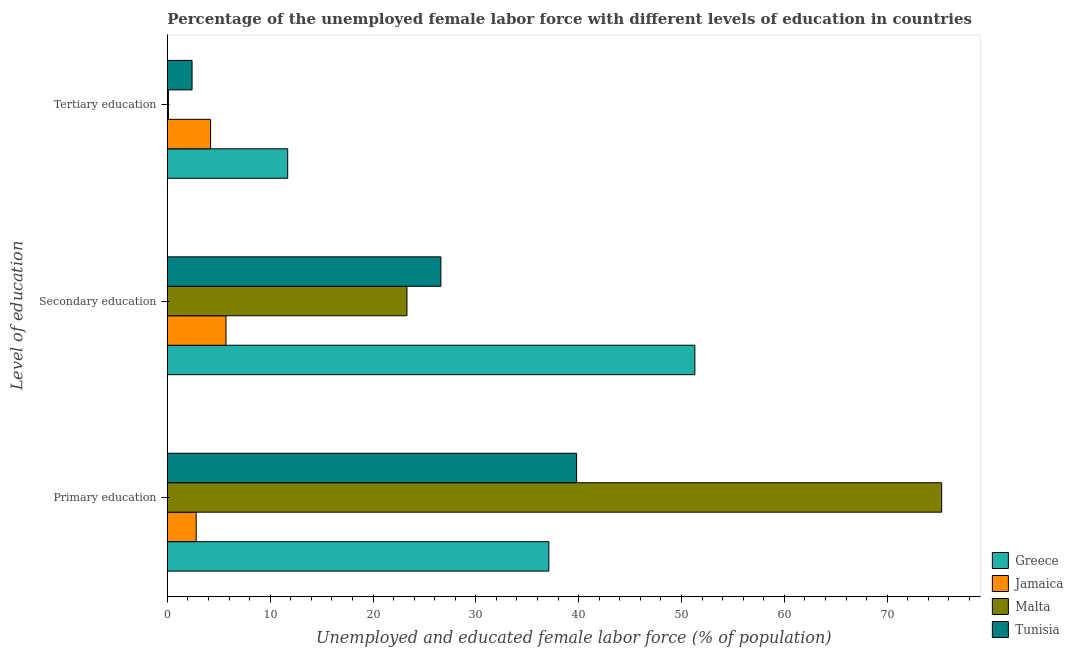How many different coloured bars are there?
Your answer should be compact. 4. Are the number of bars on each tick of the Y-axis equal?
Keep it short and to the point. Yes. How many bars are there on the 1st tick from the top?
Give a very brief answer. 4. What is the label of the 1st group of bars from the top?
Offer a very short reply. Tertiary education. What is the percentage of female labor force who received tertiary education in Malta?
Keep it short and to the point. 0.1. Across all countries, what is the maximum percentage of female labor force who received tertiary education?
Your response must be concise. 11.7. Across all countries, what is the minimum percentage of female labor force who received secondary education?
Keep it short and to the point. 5.7. In which country was the percentage of female labor force who received primary education minimum?
Keep it short and to the point. Jamaica. What is the total percentage of female labor force who received tertiary education in the graph?
Offer a very short reply. 18.4. What is the difference between the percentage of female labor force who received secondary education in Greece and that in Jamaica?
Your response must be concise. 45.6. What is the difference between the percentage of female labor force who received primary education in Greece and the percentage of female labor force who received tertiary education in Jamaica?
Give a very brief answer. 32.9. What is the average percentage of female labor force who received primary education per country?
Give a very brief answer. 38.75. What is the difference between the percentage of female labor force who received primary education and percentage of female labor force who received tertiary education in Tunisia?
Provide a short and direct response. 37.4. In how many countries, is the percentage of female labor force who received primary education greater than 72 %?
Your answer should be very brief. 1. What is the ratio of the percentage of female labor force who received secondary education in Jamaica to that in Malta?
Make the answer very short. 0.24. Is the percentage of female labor force who received secondary education in Jamaica less than that in Tunisia?
Your response must be concise. Yes. What is the difference between the highest and the second highest percentage of female labor force who received tertiary education?
Give a very brief answer. 7.5. What is the difference between the highest and the lowest percentage of female labor force who received secondary education?
Provide a short and direct response. 45.6. Is the sum of the percentage of female labor force who received primary education in Jamaica and Malta greater than the maximum percentage of female labor force who received secondary education across all countries?
Your answer should be very brief. Yes. What does the 3rd bar from the top in Secondary education represents?
Give a very brief answer. Jamaica. What does the 4th bar from the bottom in Primary education represents?
Ensure brevity in your answer.  Tunisia. How many countries are there in the graph?
Make the answer very short. 4. Are the values on the major ticks of X-axis written in scientific E-notation?
Your answer should be compact. No. How are the legend labels stacked?
Provide a succinct answer. Vertical. What is the title of the graph?
Make the answer very short. Percentage of the unemployed female labor force with different levels of education in countries. What is the label or title of the X-axis?
Make the answer very short. Unemployed and educated female labor force (% of population). What is the label or title of the Y-axis?
Your answer should be compact. Level of education. What is the Unemployed and educated female labor force (% of population) in Greece in Primary education?
Provide a succinct answer. 37.1. What is the Unemployed and educated female labor force (% of population) in Jamaica in Primary education?
Provide a succinct answer. 2.8. What is the Unemployed and educated female labor force (% of population) of Malta in Primary education?
Give a very brief answer. 75.3. What is the Unemployed and educated female labor force (% of population) of Tunisia in Primary education?
Make the answer very short. 39.8. What is the Unemployed and educated female labor force (% of population) of Greece in Secondary education?
Ensure brevity in your answer.  51.3. What is the Unemployed and educated female labor force (% of population) of Jamaica in Secondary education?
Provide a succinct answer. 5.7. What is the Unemployed and educated female labor force (% of population) of Malta in Secondary education?
Make the answer very short. 23.3. What is the Unemployed and educated female labor force (% of population) in Tunisia in Secondary education?
Ensure brevity in your answer.  26.6. What is the Unemployed and educated female labor force (% of population) of Greece in Tertiary education?
Give a very brief answer. 11.7. What is the Unemployed and educated female labor force (% of population) in Jamaica in Tertiary education?
Provide a short and direct response. 4.2. What is the Unemployed and educated female labor force (% of population) in Malta in Tertiary education?
Give a very brief answer. 0.1. What is the Unemployed and educated female labor force (% of population) of Tunisia in Tertiary education?
Ensure brevity in your answer.  2.4. Across all Level of education, what is the maximum Unemployed and educated female labor force (% of population) in Greece?
Keep it short and to the point. 51.3. Across all Level of education, what is the maximum Unemployed and educated female labor force (% of population) in Jamaica?
Make the answer very short. 5.7. Across all Level of education, what is the maximum Unemployed and educated female labor force (% of population) of Malta?
Provide a succinct answer. 75.3. Across all Level of education, what is the maximum Unemployed and educated female labor force (% of population) of Tunisia?
Offer a terse response. 39.8. Across all Level of education, what is the minimum Unemployed and educated female labor force (% of population) in Greece?
Offer a terse response. 11.7. Across all Level of education, what is the minimum Unemployed and educated female labor force (% of population) in Jamaica?
Ensure brevity in your answer.  2.8. Across all Level of education, what is the minimum Unemployed and educated female labor force (% of population) in Malta?
Provide a short and direct response. 0.1. Across all Level of education, what is the minimum Unemployed and educated female labor force (% of population) of Tunisia?
Offer a terse response. 2.4. What is the total Unemployed and educated female labor force (% of population) of Greece in the graph?
Your answer should be compact. 100.1. What is the total Unemployed and educated female labor force (% of population) in Malta in the graph?
Offer a very short reply. 98.7. What is the total Unemployed and educated female labor force (% of population) in Tunisia in the graph?
Keep it short and to the point. 68.8. What is the difference between the Unemployed and educated female labor force (% of population) of Greece in Primary education and that in Tertiary education?
Make the answer very short. 25.4. What is the difference between the Unemployed and educated female labor force (% of population) in Malta in Primary education and that in Tertiary education?
Offer a very short reply. 75.2. What is the difference between the Unemployed and educated female labor force (% of population) of Tunisia in Primary education and that in Tertiary education?
Make the answer very short. 37.4. What is the difference between the Unemployed and educated female labor force (% of population) of Greece in Secondary education and that in Tertiary education?
Keep it short and to the point. 39.6. What is the difference between the Unemployed and educated female labor force (% of population) of Malta in Secondary education and that in Tertiary education?
Offer a terse response. 23.2. What is the difference between the Unemployed and educated female labor force (% of population) of Tunisia in Secondary education and that in Tertiary education?
Provide a short and direct response. 24.2. What is the difference between the Unemployed and educated female labor force (% of population) in Greece in Primary education and the Unemployed and educated female labor force (% of population) in Jamaica in Secondary education?
Give a very brief answer. 31.4. What is the difference between the Unemployed and educated female labor force (% of population) of Greece in Primary education and the Unemployed and educated female labor force (% of population) of Tunisia in Secondary education?
Your response must be concise. 10.5. What is the difference between the Unemployed and educated female labor force (% of population) in Jamaica in Primary education and the Unemployed and educated female labor force (% of population) in Malta in Secondary education?
Offer a terse response. -20.5. What is the difference between the Unemployed and educated female labor force (% of population) of Jamaica in Primary education and the Unemployed and educated female labor force (% of population) of Tunisia in Secondary education?
Offer a terse response. -23.8. What is the difference between the Unemployed and educated female labor force (% of population) of Malta in Primary education and the Unemployed and educated female labor force (% of population) of Tunisia in Secondary education?
Provide a short and direct response. 48.7. What is the difference between the Unemployed and educated female labor force (% of population) of Greece in Primary education and the Unemployed and educated female labor force (% of population) of Jamaica in Tertiary education?
Offer a very short reply. 32.9. What is the difference between the Unemployed and educated female labor force (% of population) of Greece in Primary education and the Unemployed and educated female labor force (% of population) of Tunisia in Tertiary education?
Provide a short and direct response. 34.7. What is the difference between the Unemployed and educated female labor force (% of population) of Malta in Primary education and the Unemployed and educated female labor force (% of population) of Tunisia in Tertiary education?
Make the answer very short. 72.9. What is the difference between the Unemployed and educated female labor force (% of population) of Greece in Secondary education and the Unemployed and educated female labor force (% of population) of Jamaica in Tertiary education?
Make the answer very short. 47.1. What is the difference between the Unemployed and educated female labor force (% of population) of Greece in Secondary education and the Unemployed and educated female labor force (% of population) of Malta in Tertiary education?
Keep it short and to the point. 51.2. What is the difference between the Unemployed and educated female labor force (% of population) in Greece in Secondary education and the Unemployed and educated female labor force (% of population) in Tunisia in Tertiary education?
Make the answer very short. 48.9. What is the difference between the Unemployed and educated female labor force (% of population) of Jamaica in Secondary education and the Unemployed and educated female labor force (% of population) of Malta in Tertiary education?
Your answer should be compact. 5.6. What is the difference between the Unemployed and educated female labor force (% of population) in Malta in Secondary education and the Unemployed and educated female labor force (% of population) in Tunisia in Tertiary education?
Provide a succinct answer. 20.9. What is the average Unemployed and educated female labor force (% of population) in Greece per Level of education?
Make the answer very short. 33.37. What is the average Unemployed and educated female labor force (% of population) of Jamaica per Level of education?
Make the answer very short. 4.23. What is the average Unemployed and educated female labor force (% of population) in Malta per Level of education?
Your answer should be very brief. 32.9. What is the average Unemployed and educated female labor force (% of population) in Tunisia per Level of education?
Keep it short and to the point. 22.93. What is the difference between the Unemployed and educated female labor force (% of population) of Greece and Unemployed and educated female labor force (% of population) of Jamaica in Primary education?
Your answer should be compact. 34.3. What is the difference between the Unemployed and educated female labor force (% of population) in Greece and Unemployed and educated female labor force (% of population) in Malta in Primary education?
Ensure brevity in your answer.  -38.2. What is the difference between the Unemployed and educated female labor force (% of population) in Greece and Unemployed and educated female labor force (% of population) in Tunisia in Primary education?
Your answer should be very brief. -2.7. What is the difference between the Unemployed and educated female labor force (% of population) in Jamaica and Unemployed and educated female labor force (% of population) in Malta in Primary education?
Offer a very short reply. -72.5. What is the difference between the Unemployed and educated female labor force (% of population) of Jamaica and Unemployed and educated female labor force (% of population) of Tunisia in Primary education?
Offer a very short reply. -37. What is the difference between the Unemployed and educated female labor force (% of population) of Malta and Unemployed and educated female labor force (% of population) of Tunisia in Primary education?
Ensure brevity in your answer.  35.5. What is the difference between the Unemployed and educated female labor force (% of population) in Greece and Unemployed and educated female labor force (% of population) in Jamaica in Secondary education?
Your answer should be very brief. 45.6. What is the difference between the Unemployed and educated female labor force (% of population) of Greece and Unemployed and educated female labor force (% of population) of Tunisia in Secondary education?
Your answer should be very brief. 24.7. What is the difference between the Unemployed and educated female labor force (% of population) in Jamaica and Unemployed and educated female labor force (% of population) in Malta in Secondary education?
Keep it short and to the point. -17.6. What is the difference between the Unemployed and educated female labor force (% of population) in Jamaica and Unemployed and educated female labor force (% of population) in Tunisia in Secondary education?
Your response must be concise. -20.9. What is the difference between the Unemployed and educated female labor force (% of population) in Malta and Unemployed and educated female labor force (% of population) in Tunisia in Secondary education?
Ensure brevity in your answer.  -3.3. What is the difference between the Unemployed and educated female labor force (% of population) in Greece and Unemployed and educated female labor force (% of population) in Jamaica in Tertiary education?
Your answer should be compact. 7.5. What is the difference between the Unemployed and educated female labor force (% of population) in Greece and Unemployed and educated female labor force (% of population) in Tunisia in Tertiary education?
Provide a short and direct response. 9.3. What is the difference between the Unemployed and educated female labor force (% of population) in Malta and Unemployed and educated female labor force (% of population) in Tunisia in Tertiary education?
Your response must be concise. -2.3. What is the ratio of the Unemployed and educated female labor force (% of population) in Greece in Primary education to that in Secondary education?
Your answer should be very brief. 0.72. What is the ratio of the Unemployed and educated female labor force (% of population) of Jamaica in Primary education to that in Secondary education?
Offer a very short reply. 0.49. What is the ratio of the Unemployed and educated female labor force (% of population) of Malta in Primary education to that in Secondary education?
Provide a short and direct response. 3.23. What is the ratio of the Unemployed and educated female labor force (% of population) of Tunisia in Primary education to that in Secondary education?
Your answer should be compact. 1.5. What is the ratio of the Unemployed and educated female labor force (% of population) in Greece in Primary education to that in Tertiary education?
Your answer should be compact. 3.17. What is the ratio of the Unemployed and educated female labor force (% of population) of Malta in Primary education to that in Tertiary education?
Provide a succinct answer. 753. What is the ratio of the Unemployed and educated female labor force (% of population) of Tunisia in Primary education to that in Tertiary education?
Your response must be concise. 16.58. What is the ratio of the Unemployed and educated female labor force (% of population) in Greece in Secondary education to that in Tertiary education?
Ensure brevity in your answer.  4.38. What is the ratio of the Unemployed and educated female labor force (% of population) of Jamaica in Secondary education to that in Tertiary education?
Give a very brief answer. 1.36. What is the ratio of the Unemployed and educated female labor force (% of population) in Malta in Secondary education to that in Tertiary education?
Your response must be concise. 233. What is the ratio of the Unemployed and educated female labor force (% of population) of Tunisia in Secondary education to that in Tertiary education?
Make the answer very short. 11.08. What is the difference between the highest and the second highest Unemployed and educated female labor force (% of population) of Jamaica?
Offer a very short reply. 1.5. What is the difference between the highest and the lowest Unemployed and educated female labor force (% of population) of Greece?
Provide a succinct answer. 39.6. What is the difference between the highest and the lowest Unemployed and educated female labor force (% of population) in Jamaica?
Offer a terse response. 2.9. What is the difference between the highest and the lowest Unemployed and educated female labor force (% of population) in Malta?
Offer a very short reply. 75.2. What is the difference between the highest and the lowest Unemployed and educated female labor force (% of population) in Tunisia?
Provide a succinct answer. 37.4. 